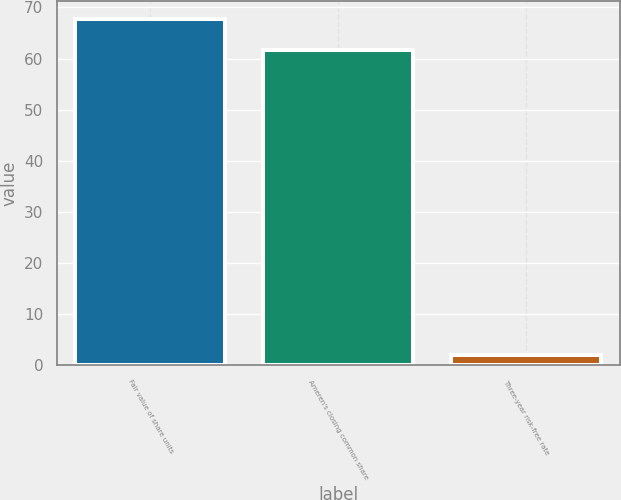<chart> <loc_0><loc_0><loc_500><loc_500><bar_chart><fcel>Fair value of share units<fcel>Ameren's closing common share<fcel>Three-year risk-free rate<nl><fcel>67.78<fcel>61.69<fcel>1.98<nl></chart> 